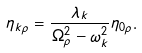Convert formula to latex. <formula><loc_0><loc_0><loc_500><loc_500>\eta _ { k \rho } = \frac { \lambda _ { k } } { \Omega _ { \rho } ^ { 2 } - \omega _ { k } ^ { 2 } } \eta _ { 0 \rho } .</formula> 